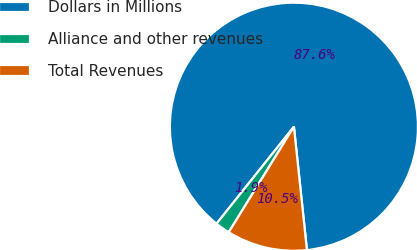Convert chart. <chart><loc_0><loc_0><loc_500><loc_500><pie_chart><fcel>Dollars in Millions<fcel>Alliance and other revenues<fcel>Total Revenues<nl><fcel>87.6%<fcel>1.91%<fcel>10.48%<nl></chart> 